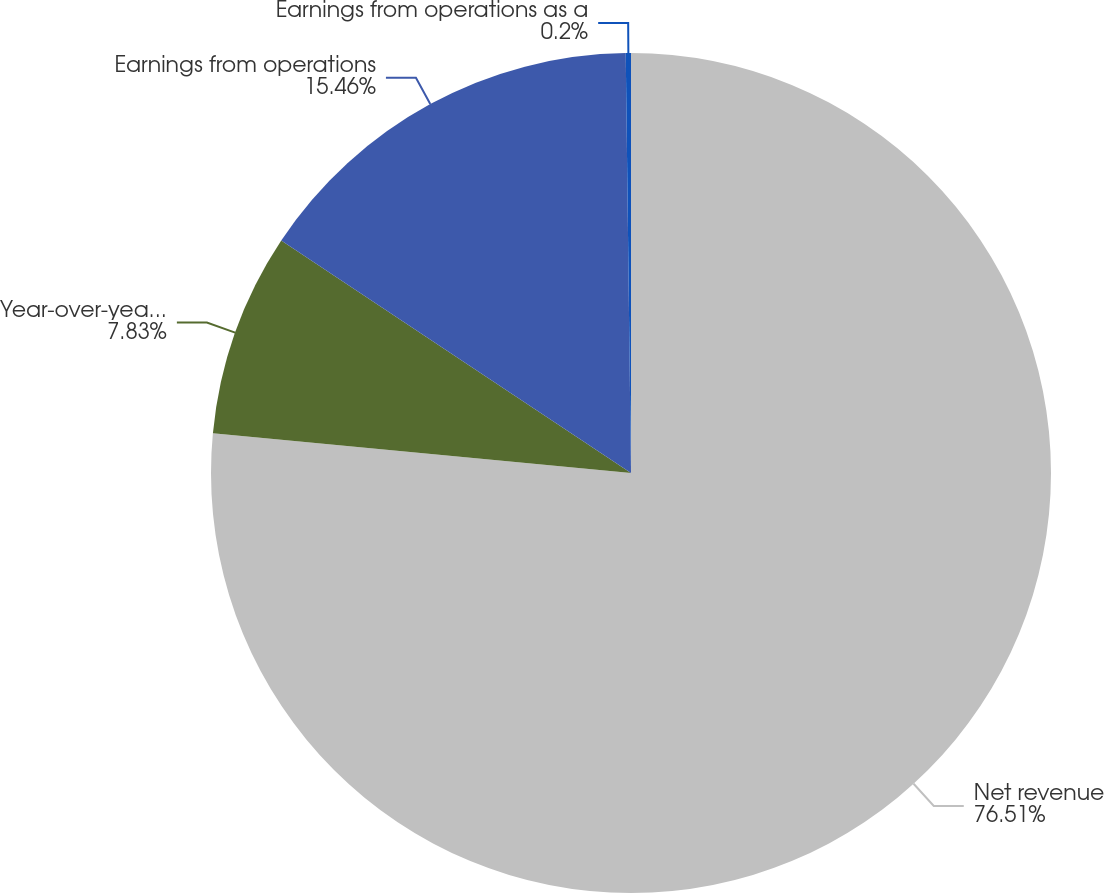<chart> <loc_0><loc_0><loc_500><loc_500><pie_chart><fcel>Net revenue<fcel>Year-over-year net revenue<fcel>Earnings from operations<fcel>Earnings from operations as a<nl><fcel>76.5%<fcel>7.83%<fcel>15.46%<fcel>0.2%<nl></chart> 